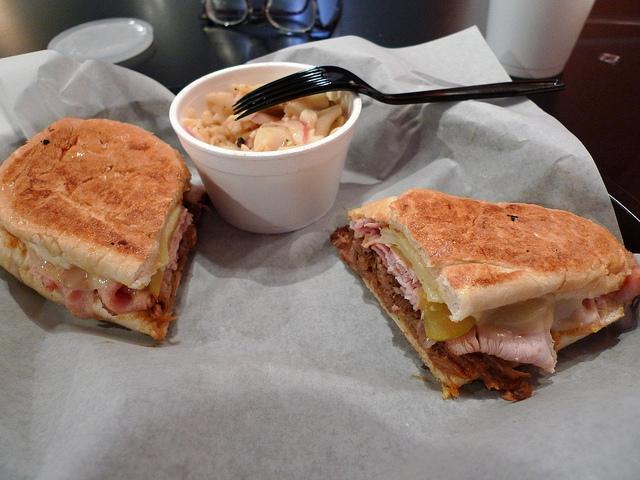How many bowls are visible?
Give a very brief answer. 1. How many sandwiches are in the photo?
Give a very brief answer. 2. 